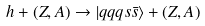<formula> <loc_0><loc_0><loc_500><loc_500>h + ( Z , A ) \to | q q q s \bar { s } \rangle + ( Z , A )</formula> 